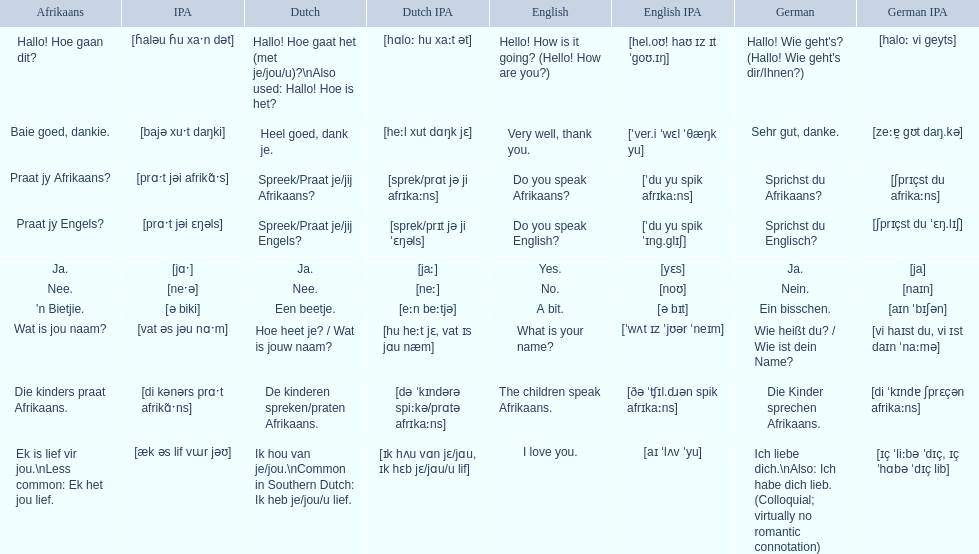In german how do you say do you speak afrikaans? Sprichst du Afrikaans?. How do you say it in afrikaans? Praat jy Afrikaans?. 